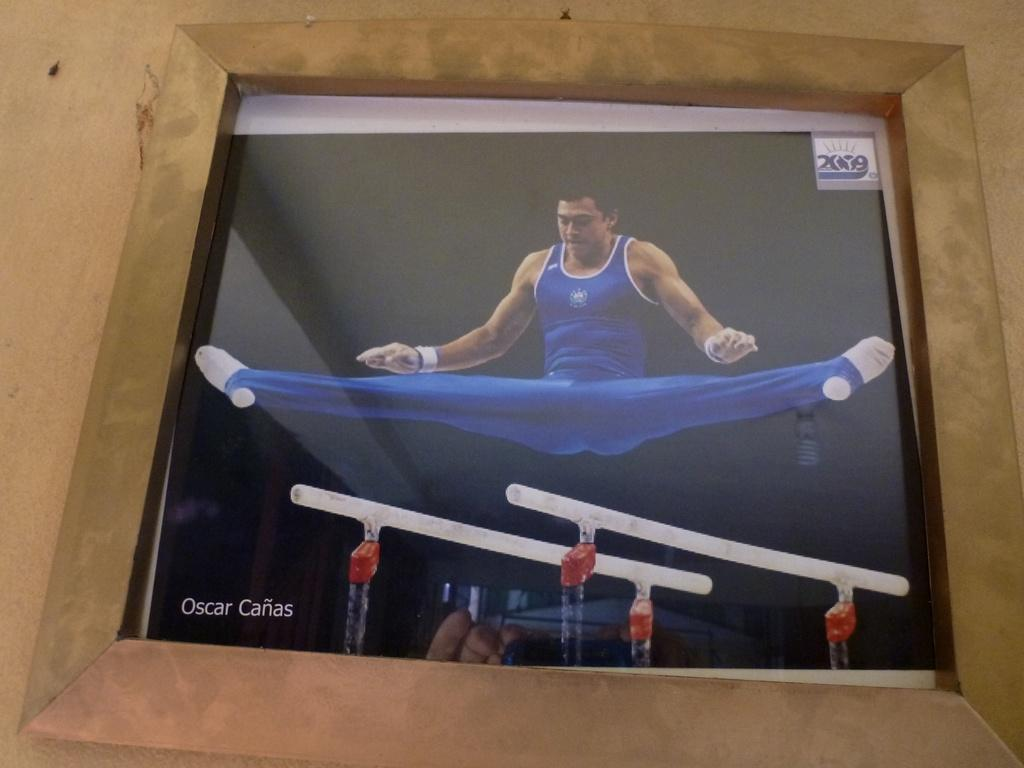<image>
Offer a succinct explanation of the picture presented. A male gymnist is over two bars and the name, oscar canas, is below it. 